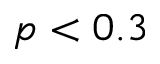Convert formula to latex. <formula><loc_0><loc_0><loc_500><loc_500>p < 0 . 3</formula> 